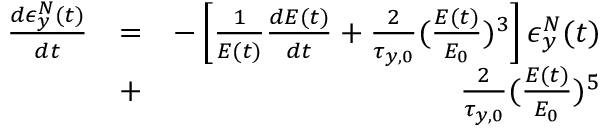Convert formula to latex. <formula><loc_0><loc_0><loc_500><loc_500>\begin{array} { r l r } { \frac { d \epsilon _ { y } ^ { N } ( t ) } { d t } } & { = } & { - \left [ \frac { 1 } { E ( t ) } \frac { d E ( t ) } { d t } + \frac { 2 } { \tau _ { y , 0 } } ( \frac { E ( t ) } { E _ { 0 } } ) ^ { 3 } \right ] \epsilon _ { y } ^ { N } ( t ) } \\ & { + } & { \frac { 2 } { \tau _ { y , 0 } } ( \frac { E ( t ) } { E _ { 0 } } ) ^ { 5 } } \end{array}</formula> 